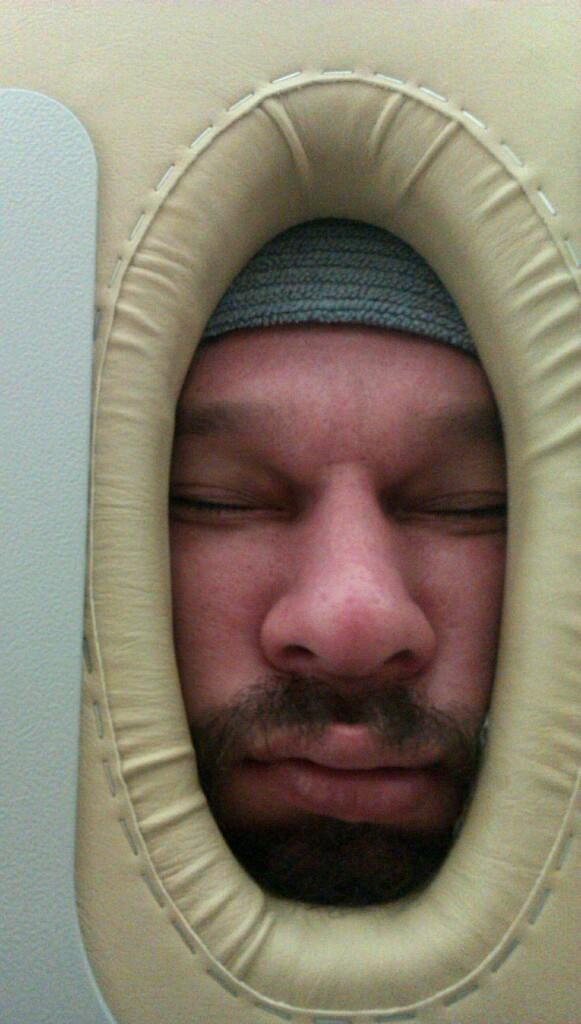What is the main subject of the image? The main subject of the image is an object with a human face. Can you describe the object with the human face? Unfortunately, the facts provided do not give any specific details about the object. However, we can confirm that there is a human face in an object in the image. What type of shoes is the person wearing in the image? There is no person present in the image, only an object with a human face. Therefore, we cannot determine what type of shoes the person might be wearing. 